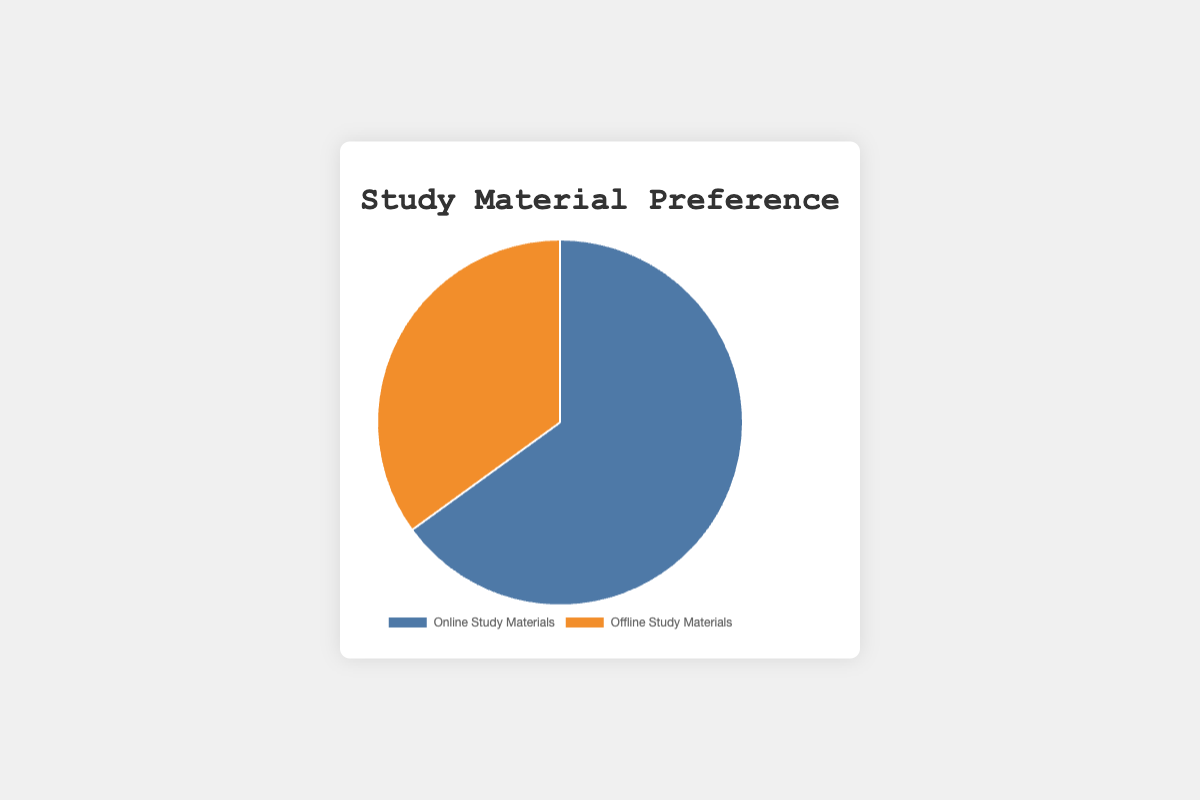Which study material type has the higher preference percentage? By looking at the pie chart, we can directly see that the "Online Study Materials" segment is larger than the "Offline Study Materials" segment. This indicates higher preference.
Answer: Online Study Materials What percentage of people prefer offline study materials? The exact percentage is labeled on the pie chart. The offline study materials segment shows a preference of 35%.
Answer: 35% How much higher is the preference for online study materials compared to offline study materials? We need to subtract the percentage of offline study materials from the percentage of online study materials: 65% - 35% = 30%.
Answer: 30% Which study material type has a larger segment visually in the pie chart? By observing the visual representation of the segments, the "Online Study Materials" segment has a visibly larger size.
Answer: Online Study Materials Are the preferences for online and offline study materials equal? Observing the pie chart, the two segments are not the same size, indicating that the preferences are not equal.
Answer: No What is the combined preference percentage for both study material types shown in the pie chart? Adding the two percentages together: 65% (Online) + 35% (Offline) = 100%.
Answer: 100% If the preference for online study materials decreased by 10%, what would be the new percentage for online study materials? Subtracting 10% from the current 65%: 65% - 10% = 55%.
Answer: 55% What is the difference in percentage between the preferred online study material "Coursera" and the least preferred offline study material "Library Books"? From the data provided: 20% (Coursera) - 5% (Library Books) = 15%.
Answer: 15% Which has a higher preference, "YouTube Educational Channels" or "Textbooks"? Observing the data: "YouTube Educational Channels" has 10%, whereas "Textbooks" has 20%.
Answer: Textbooks Is there any study material entity within the online or offline categories with the exact same preference percentage? From the data, "Khan Academy," "YouTube Educational Channels," and "MIT OpenCourseWare" all have 10% within online study materials.
Answer: Yes 